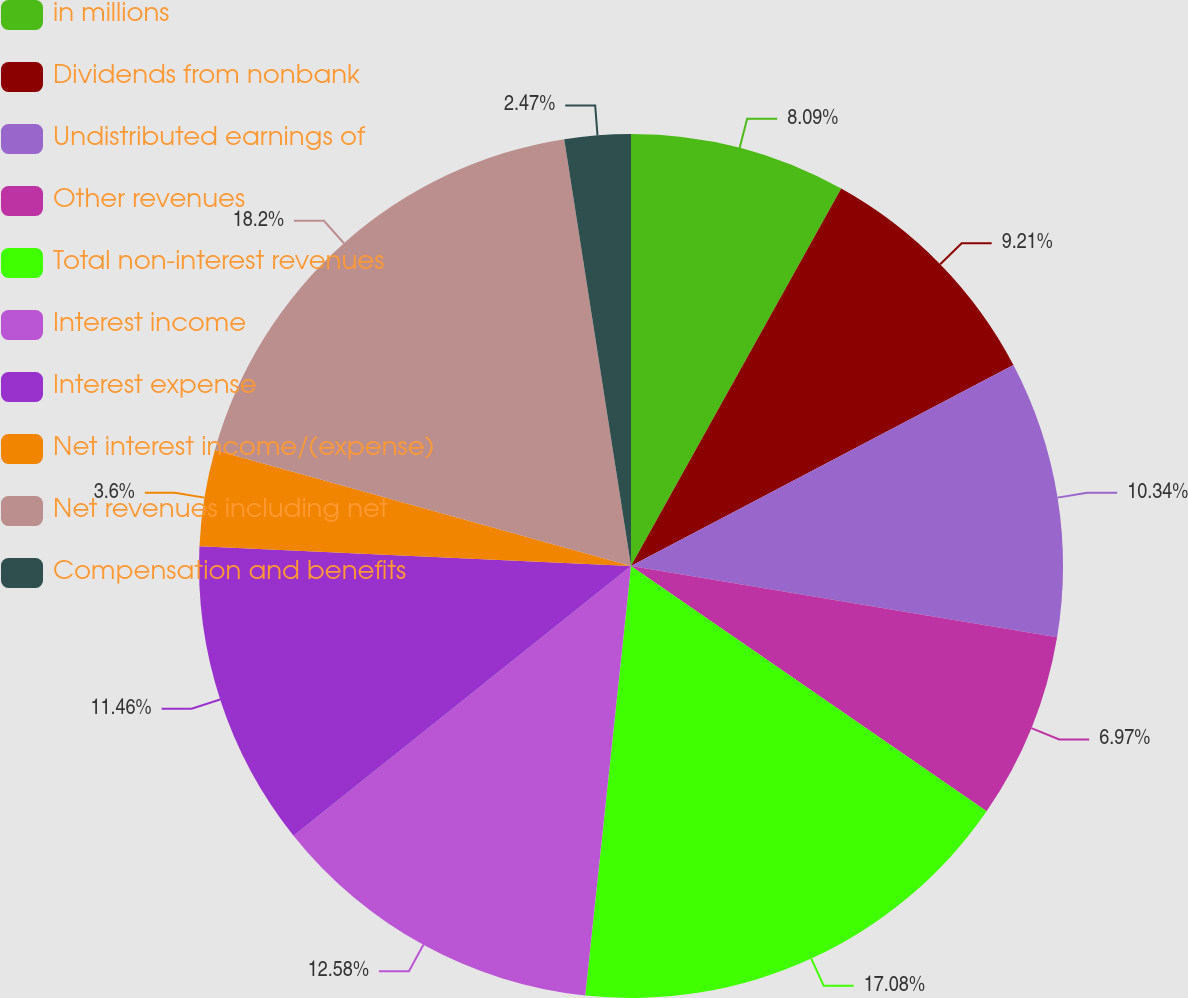Convert chart. <chart><loc_0><loc_0><loc_500><loc_500><pie_chart><fcel>in millions<fcel>Dividends from nonbank<fcel>Undistributed earnings of<fcel>Other revenues<fcel>Total non-interest revenues<fcel>Interest income<fcel>Interest expense<fcel>Net interest income/(expense)<fcel>Net revenues including net<fcel>Compensation and benefits<nl><fcel>8.09%<fcel>9.21%<fcel>10.34%<fcel>6.97%<fcel>17.08%<fcel>12.58%<fcel>11.46%<fcel>3.6%<fcel>18.2%<fcel>2.47%<nl></chart> 